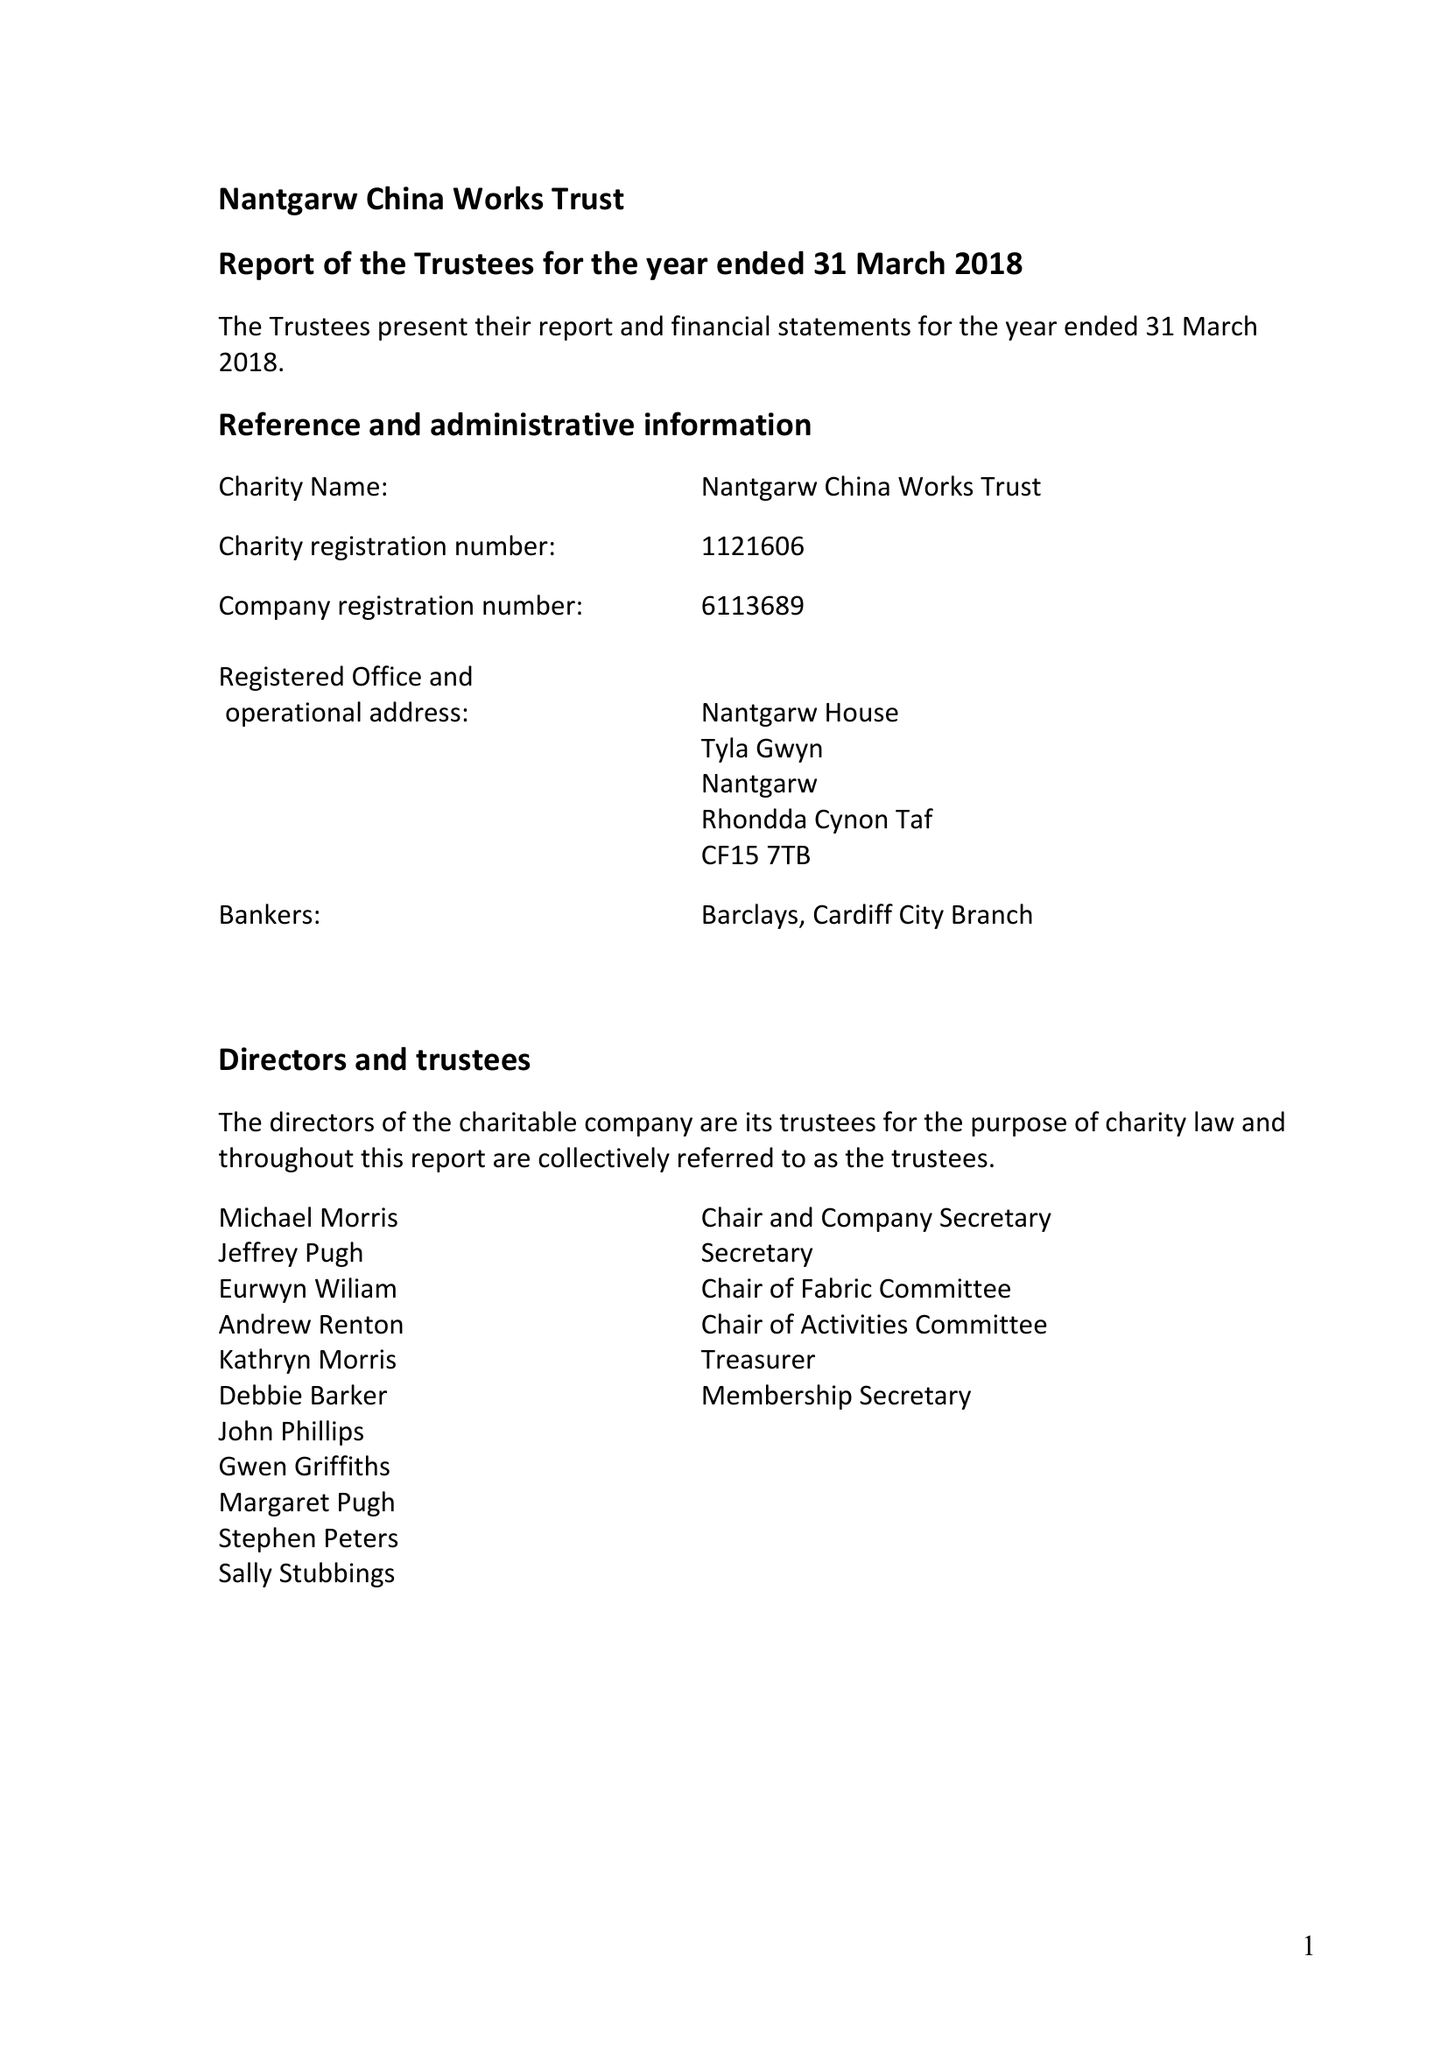What is the value for the address__street_line?
Answer the question using a single word or phrase. TYLA GWYN 